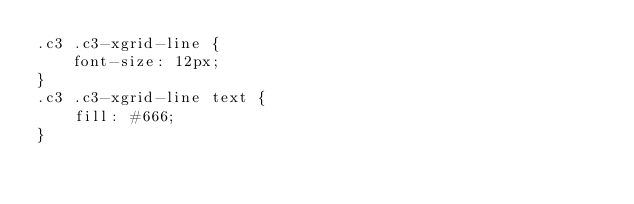<code> <loc_0><loc_0><loc_500><loc_500><_CSS_>.c3 .c3-xgrid-line {
    font-size: 12px;
}
.c3 .c3-xgrid-line text {
    fill: #666;
}</code> 